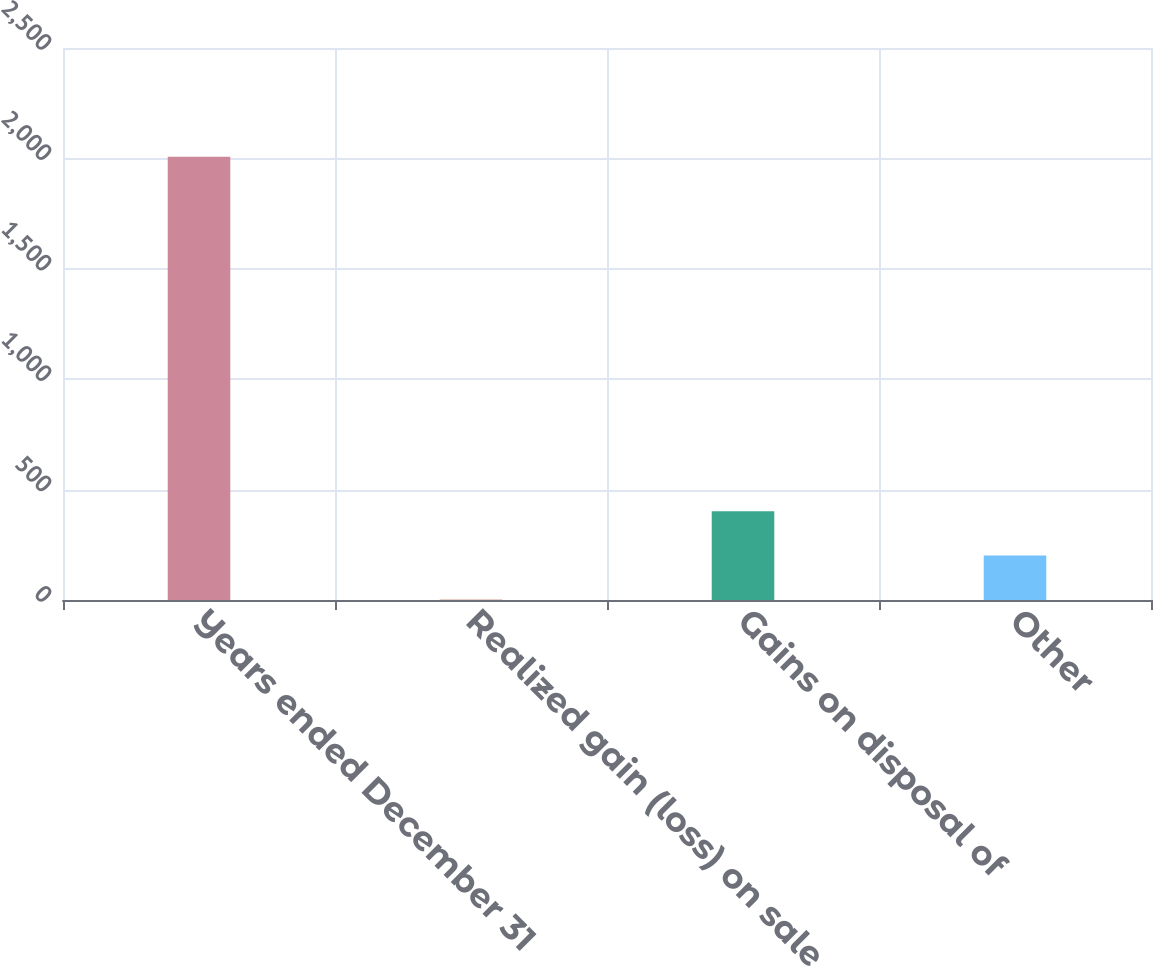Convert chart to OTSL. <chart><loc_0><loc_0><loc_500><loc_500><bar_chart><fcel>Years ended December 31<fcel>Realized gain (loss) on sale<fcel>Gains on disposal of<fcel>Other<nl><fcel>2008<fcel>1<fcel>402.4<fcel>201.7<nl></chart> 